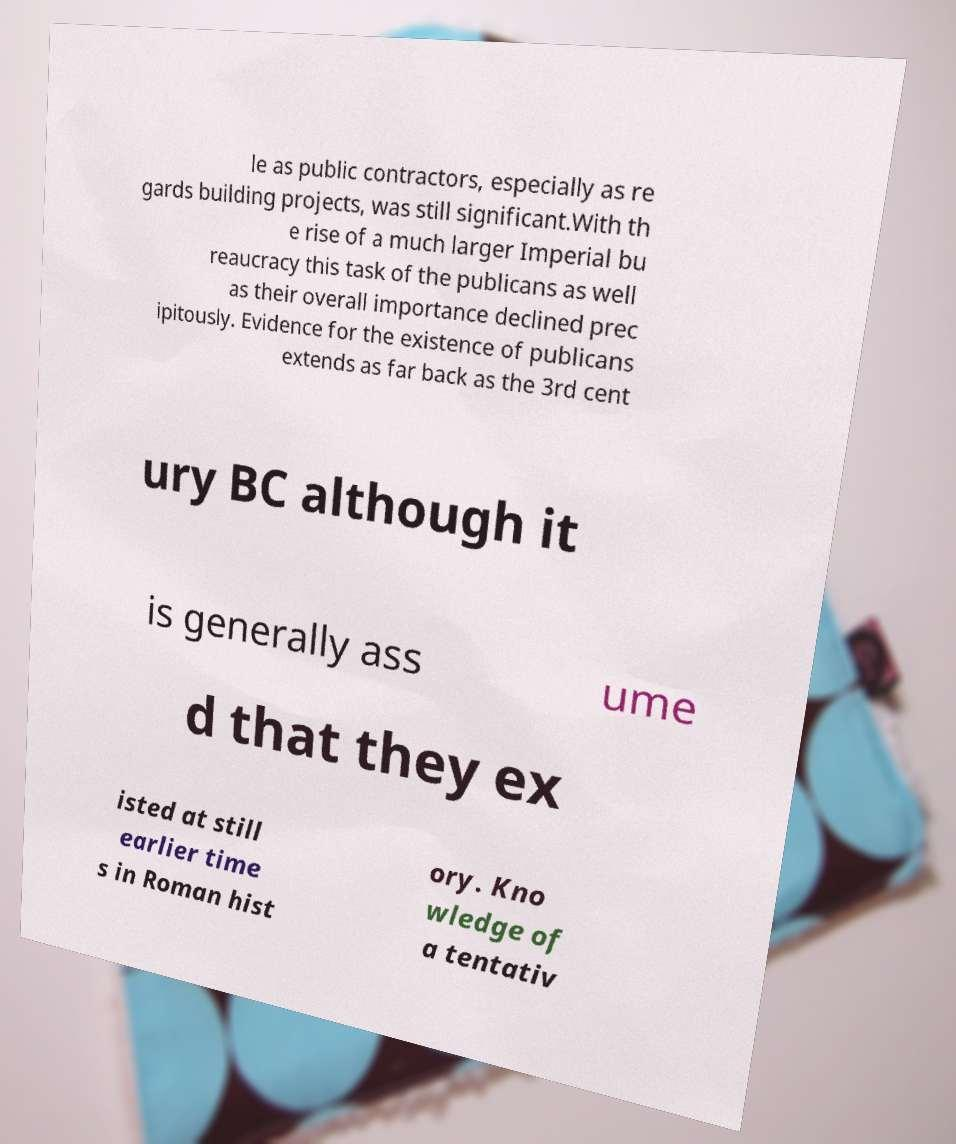There's text embedded in this image that I need extracted. Can you transcribe it verbatim? le as public contractors, especially as re gards building projects, was still significant.With th e rise of a much larger Imperial bu reaucracy this task of the publicans as well as their overall importance declined prec ipitously. Evidence for the existence of publicans extends as far back as the 3rd cent ury BC although it is generally ass ume d that they ex isted at still earlier time s in Roman hist ory. Kno wledge of a tentativ 